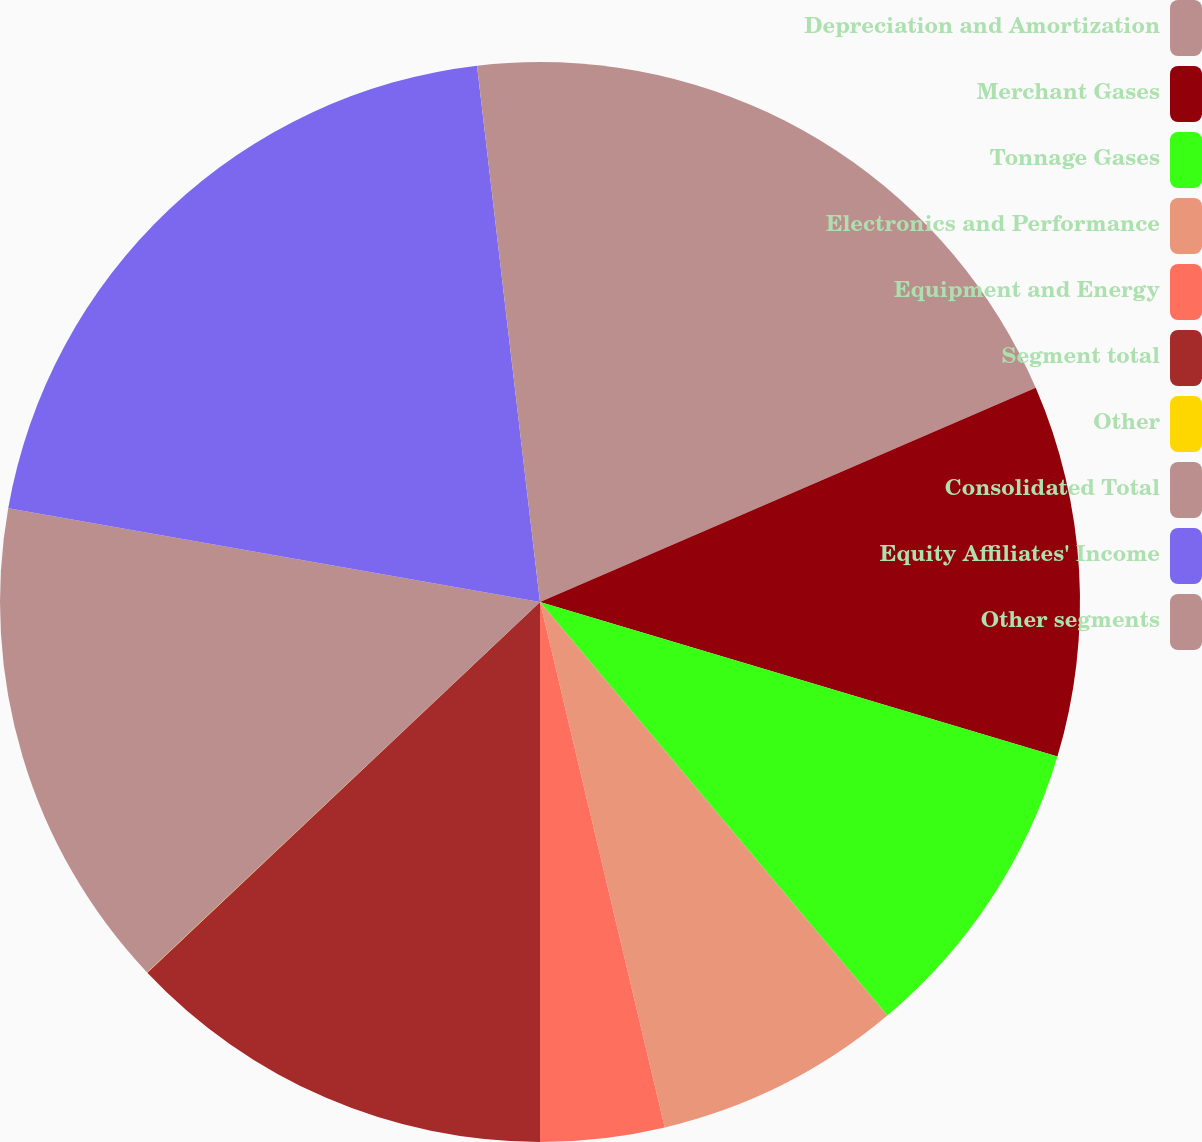Convert chart. <chart><loc_0><loc_0><loc_500><loc_500><pie_chart><fcel>Depreciation and Amortization<fcel>Merchant Gases<fcel>Tonnage Gases<fcel>Electronics and Performance<fcel>Equipment and Energy<fcel>Segment total<fcel>Other<fcel>Consolidated Total<fcel>Equity Affiliates' Income<fcel>Other segments<nl><fcel>18.51%<fcel>11.11%<fcel>9.26%<fcel>7.41%<fcel>3.71%<fcel>12.96%<fcel>0.01%<fcel>14.81%<fcel>20.36%<fcel>1.86%<nl></chart> 